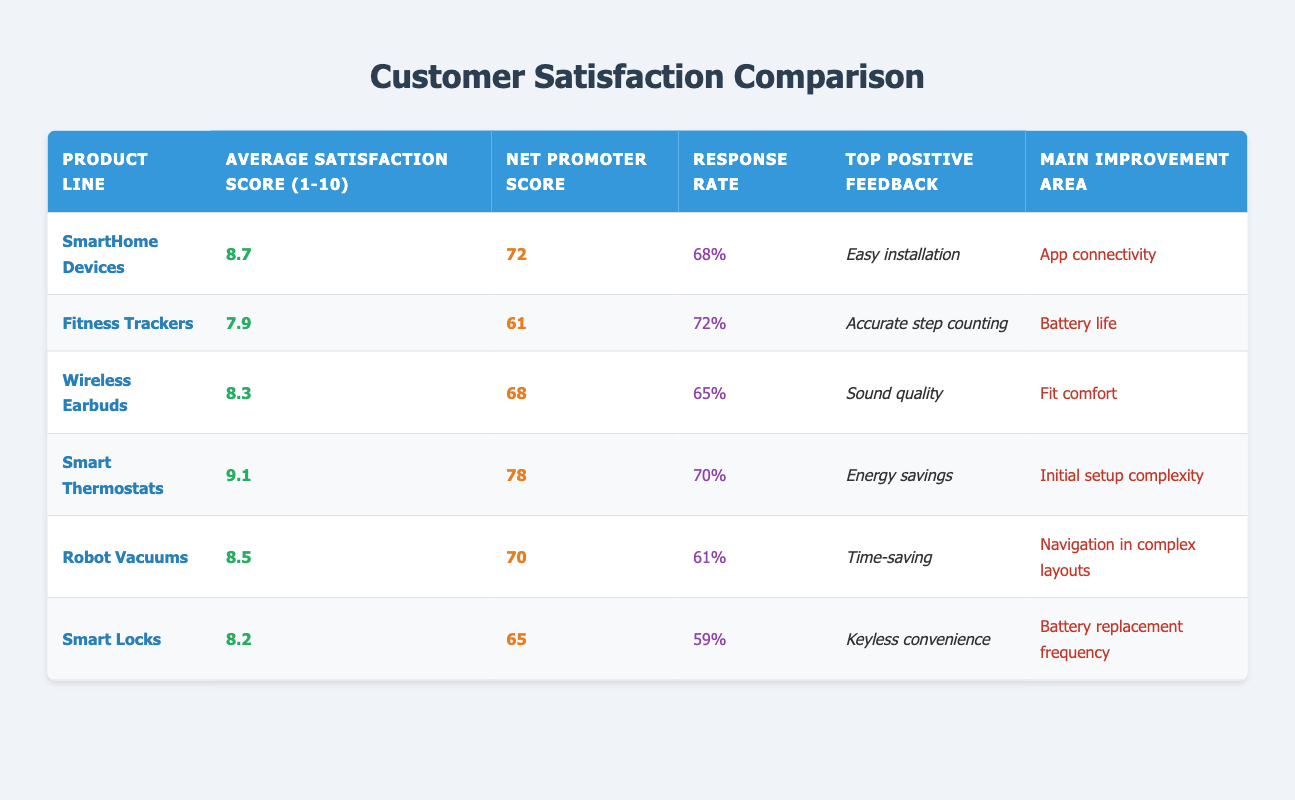What is the Average Satisfaction Score for SmartHome Devices? The table shows that the Average Satisfaction Score for SmartHome Devices is listed as 8.7.
Answer: 8.7 Which product line has the highest Net Promoter Score? By reviewing the Net Promoter Scores displayed, Smart Thermostats has the highest score at 78.
Answer: 78 How does the Response Rate for Robot Vacuums compare to that of Smart Locks? The Response Rate for Robot Vacuums is 61% and for Smart Locks is 59%. Robot Vacuums have a slightly higher Response Rate.
Answer: Robot Vacuums have a higher Response Rate What is the difference between the Average Satisfaction Scores of Smart Thermostats and Fitness Trackers? Smart Thermostats have an Average Satisfaction Score of 9.1, and Fitness Trackers have 7.9. Calculating the difference: 9.1 - 7.9 = 1.2.
Answer: 1.2 Is the Main Improvement Area for SmartHome Devices related to App connectivity? Yes, according to the table, the Main Improvement Area for SmartHome Devices is indeed listed as App connectivity.
Answer: Yes Which product line has the least percentage of Response Rate and what is that percentage? Evaluating the Response Rates, Smart Locks at 59% has the least percentage.
Answer: Smart Locks, 59% What is the average of the Average Satisfaction Scores for all product lines? The Average Satisfaction Scores are: 8.7 (SmartHome Devices), 7.9 (Fitness Trackers), 8.3 (Wireless Earbuds), 9.1 (Smart Thermostats), 8.5 (Robot Vacuums), and 8.2 (Smart Locks). Adding these yields a total of 51.7 and there are 6 products: 51.7 / 6 = 8.62.
Answer: 8.62 How many product lines have a Net Promoter Score higher than 70? Reviewing the Net Promoter Scores: Smart Thermostats (78), SmartHome Devices (72), and Robot Vacuums (70) meet this criterion, thus there are 3 product lines with scores higher than 70.
Answer: 3 Which product line had the top positive feedback related to energy savings? Looking at the Top Positive Feedback section, Smart Thermostats received feedback specifically mentioning energy savings as its highlight.
Answer: Smart Thermostats 